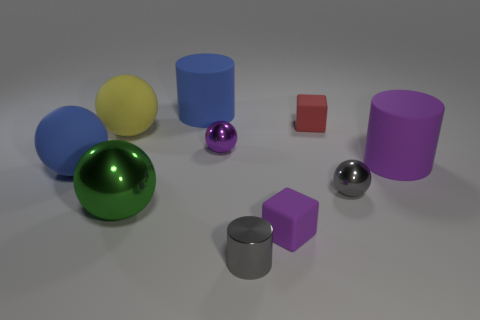Subtract all cylinders. How many objects are left? 7 Subtract 2 cylinders. How many cylinders are left? 1 Subtract all brown cylinders. Subtract all blue spheres. How many cylinders are left? 3 Subtract all red cubes. How many green spheres are left? 1 Subtract all yellow rubber spheres. Subtract all large green shiny objects. How many objects are left? 8 Add 1 large blue balls. How many large blue balls are left? 2 Add 5 small metal cylinders. How many small metal cylinders exist? 6 Subtract all blue cylinders. How many cylinders are left? 2 Subtract all large blue balls. How many balls are left? 4 Subtract 0 blue blocks. How many objects are left? 10 